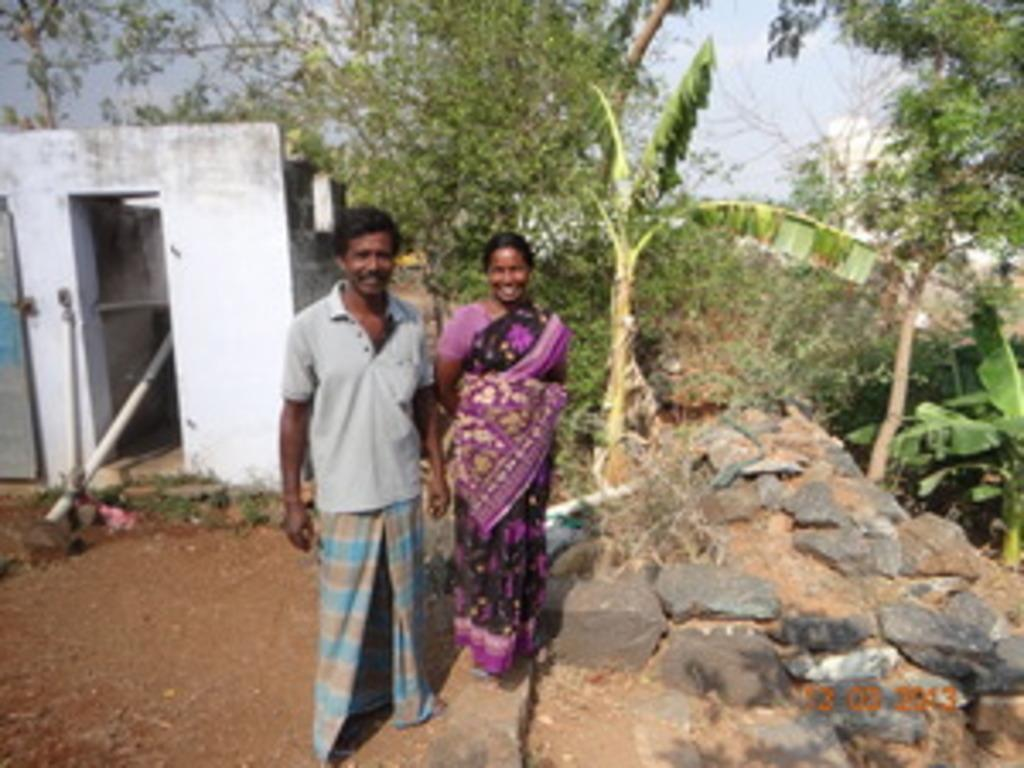How many people are present in the image? There are two people, a man and a woman, present in the image. What are the man and woman doing in the image? Both the man and woman are standing on the road. What can be seen in the background of the image? In the background of the image, there are pipelines, doors, the sky, clouds, trees, and rocks. Can you describe the sky in the image? The sky is visible in the background of the image, and it contains clouds. What type of brush can be seen in the hands of the man in the image? There is no brush present in the image; the man is not holding any object. What is the acoustics like in the image? The provided facts do not give any information about the acoustics in the image. 